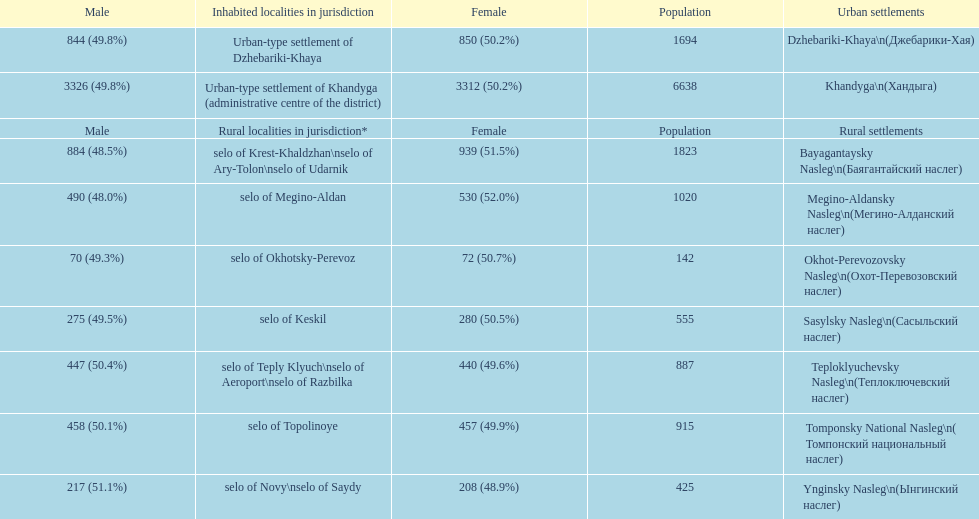Can you give me this table as a dict? {'header': ['Male', 'Inhabited localities in jurisdiction', 'Female', 'Population', 'Urban settlements'], 'rows': [['844 (49.8%)', 'Urban-type settlement of Dzhebariki-Khaya', '850 (50.2%)', '1694', 'Dzhebariki-Khaya\\n(Джебарики-Хая)'], ['3326 (49.8%)', 'Urban-type settlement of Khandyga (administrative centre of the district)', '3312 (50.2%)', '6638', 'Khandyga\\n(Хандыга)'], ['Male', 'Rural localities in jurisdiction*', 'Female', 'Population', 'Rural settlements'], ['884 (48.5%)', 'selo of Krest-Khaldzhan\\nselo of Ary-Tolon\\nselo of Udarnik', '939 (51.5%)', '1823', 'Bayagantaysky Nasleg\\n(Баягантайский наслег)'], ['490 (48.0%)', 'selo of Megino-Aldan', '530 (52.0%)', '1020', 'Megino-Aldansky Nasleg\\n(Мегино-Алданский наслег)'], ['70 (49.3%)', 'selo of Okhotsky-Perevoz', '72 (50.7%)', '142', 'Okhot-Perevozovsky Nasleg\\n(Охот-Перевозовский наслег)'], ['275 (49.5%)', 'selo of Keskil', '280 (50.5%)', '555', 'Sasylsky Nasleg\\n(Сасыльский наслег)'], ['447 (50.4%)', 'selo of Teply Klyuch\\nselo of Aeroport\\nselo of Razbilka', '440 (49.6%)', '887', 'Teploklyuchevsky Nasleg\\n(Теплоключевский наслег)'], ['458 (50.1%)', 'selo of Topolinoye', '457 (49.9%)', '915', 'Tomponsky National Nasleg\\n( Томпонский национальный наслег)'], ['217 (51.1%)', 'selo of Novy\\nselo of Saydy', '208 (48.9%)', '425', 'Ynginsky Nasleg\\n(Ынгинский наслег)']]} What is the total population in dzhebariki-khaya? 1694. 